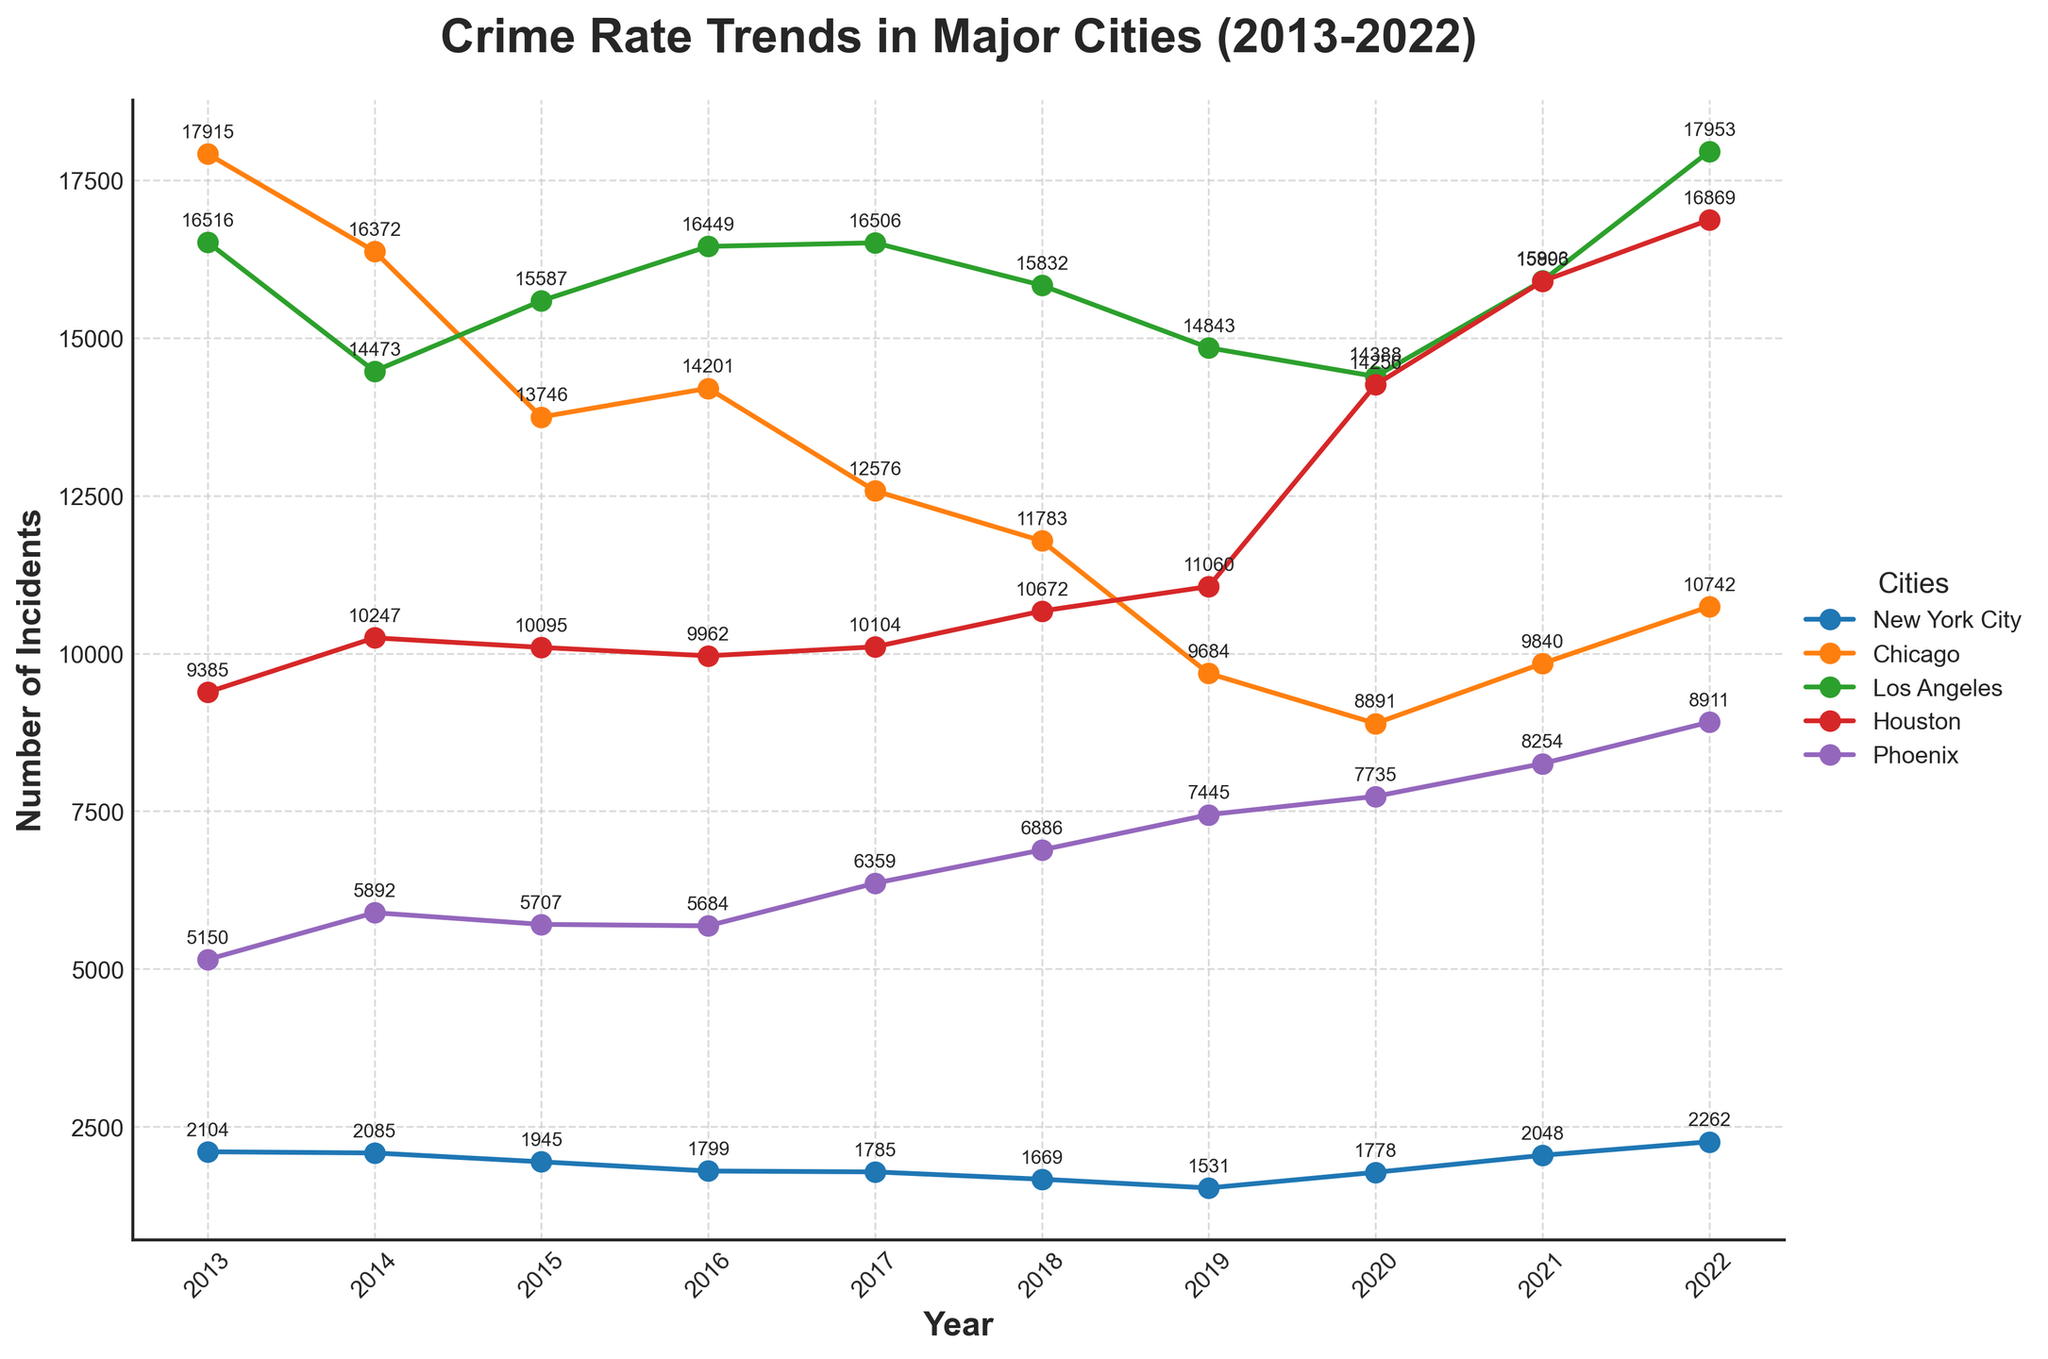Which city saw the highest increase in the crime rate from 2019 to 2022? To determine the city with the highest increase, look at the crime rates in 2019 and 2022 for each city. The differences are: New York City: 2262 - 1531 = 731, Chicago: 10742 - 9684 = 1058, Los Angeles: 17953 - 14843 = 3110, Houston: 16869 - 11060 = 5809, Phoenix: 8911 - 7445 = 1466. The highest increase is in Houston.
Answer: Houston Which city had the most consistent crime rate trend from 2013 to 2022? Consistent trend means the crime rate either consistently increased or decreased. New York City's trend generally increased or stayed stable. Chicago and Phoenix show more fluctuations. Los Angeles and Houston initially increase, but then show mixed trends, though Houston shows a consistent rise toward 2022. Therefore, New York City had the most consistent trend toward an increase.
Answer: New York City What was the average crime rate in Los Angeles from 2013 to 2022? Add the crime rates from 2013 to 2022: (16516 + 14473 + 15587 + 16449 + 16506 + 15832 + 14843 + 14388 + 15903 + 17953) = 158450. There are 10 years, so the average is 158450/10 = 15845.
Answer: 15845 Which two cities had the closest crime rates in 2021? Look at 2021 values: New York City 2048, Chicago 9840, Los Angeles 15903, Houston 15896, Phoenix 8254. Compare the differences, the closest values are Los Angeles vs. Houston:
Answer: Los Angeles and Houston By how much did the crime rate in Phoenix rise from 2018 to 2019? Check the values: Phoenix 2018: 6886, Phoenix 2019: 7445. Difference: 7445 - 6886 = 559.
Answer: 559 Rank the cities by crime rate in 2020 from highest to lowest. 2020 values: New York City 1778, Chicago 8891, Los Angeles 14388, Houston 14256, Phoenix 7735. Ranking them: 1st Los Angeles, 2nd Houston, 3rd Chicago, 4th Phoenix, 5th New York City.
Answer: Los Angeles, Houston, Chicago, Phoenix, New York City Which city showed the highest crime rate in any single year? Check all years, the highest value is Los Angeles in 2022 with 17953 incidents.
Answer: Los Angeles What is the difference between the highest and lowest crime rates in Chicago from 2013 to 2022? Chicago: Highest: 17915 (2013), Lowest: 8891 (2020). Difference: 17915 - 8891 = 9024.
Answer: 9024 In which year did New York City see the largest drop in crime rate? Look at year-to-year drops: 2019 to 2020: 1531 to 1778, drop of 247. 2016 to 2017: 1799 to 1785, drop of 114. The largest drop was between 2019 and 2020.
Answer: 2020 How did the crime rate in Houston change from 2017 to 2020? Check 2017: 10104, and 2020: 14256. The difference is 14256 - 10104 = 4152, indicating an increase.
Answer: Increased by 4152 